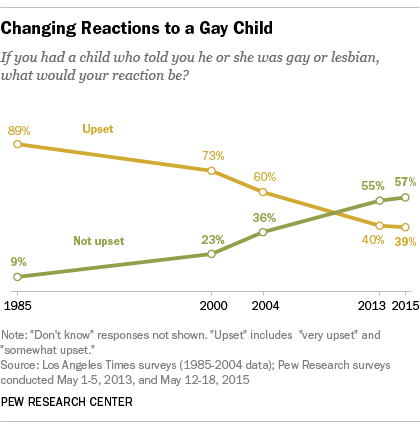Point out several critical features in this image. In 2015, a small proportion of respondents, approximately 0.39%, reported being upset upon learning that a friend or family member had a gay child. The difference between the upset and not upset graphs is maximum in the year 1985. 